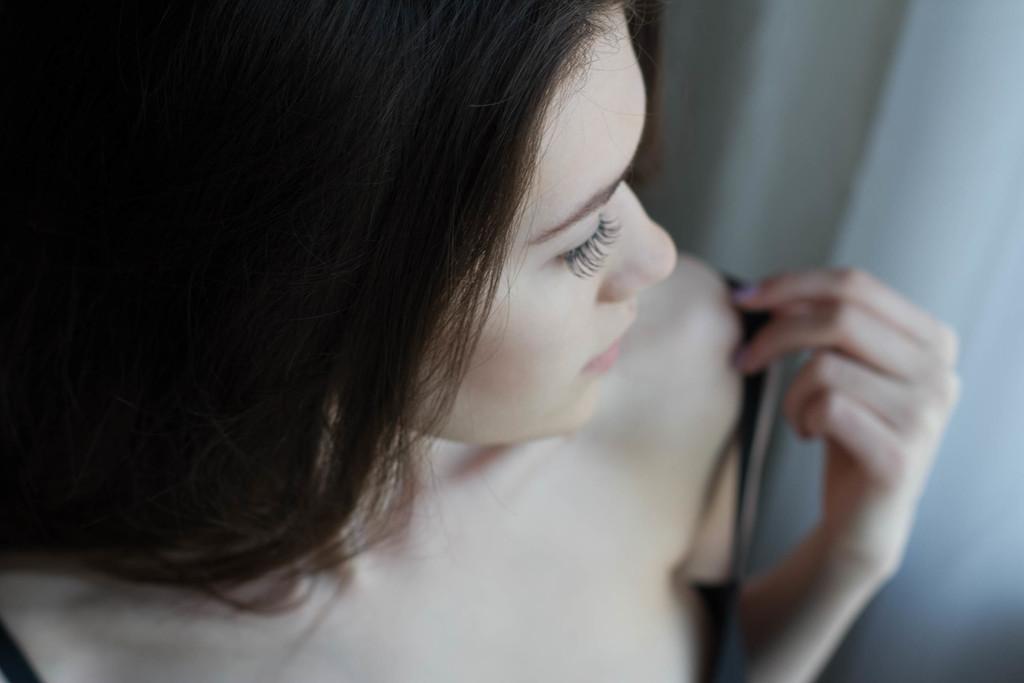Could you give a brief overview of what you see in this image? In this image there is a girl. On the right side there is a white colour curtain. 